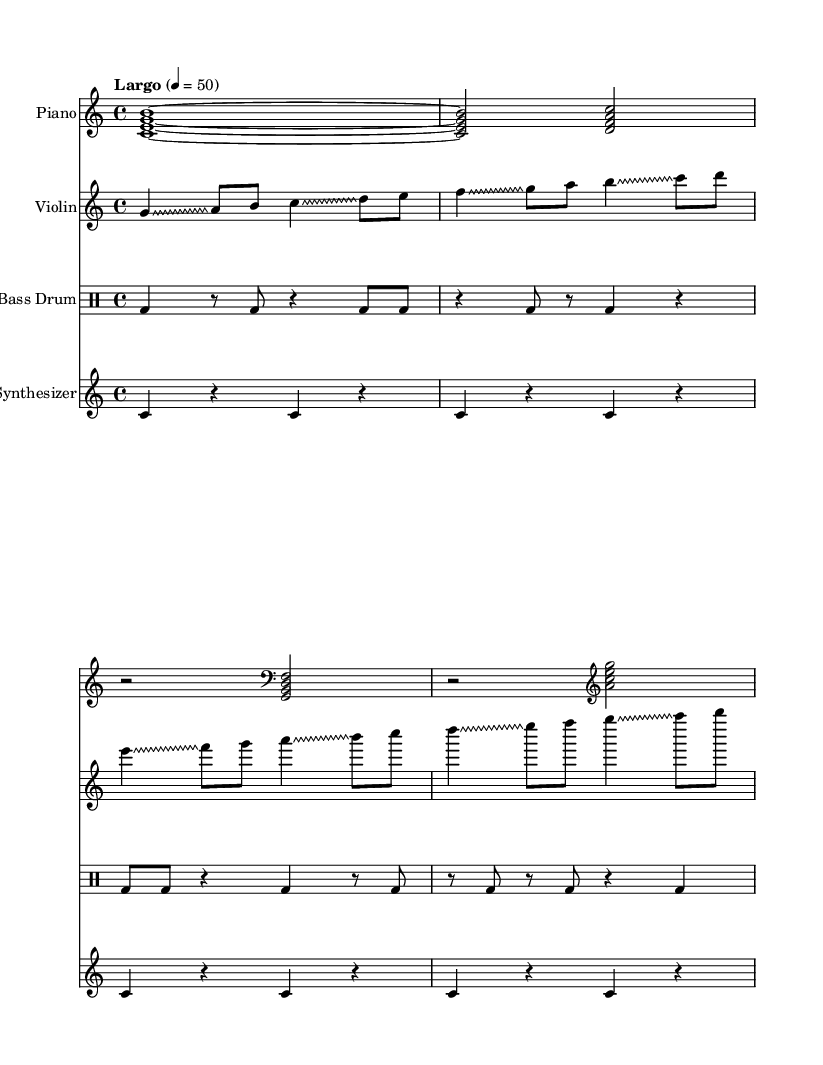What is the time signature of this music? The time signature is indicated at the beginning of the score, shown as "4/4", which means there are four beats in each measure and each beat is a quarter note.
Answer: 4/4 What is the tempo marking for the piece? The tempo marking is specified at the beginning as "Largo" with a metronome marking of 50 beats per minute, indicating a slow pace.
Answer: Largo, 50 Which instrument plays the highest pitch notes? The violin part is written in the treble clef and contains the highest pitches, as indicated by the relative note placements compared to other instruments.
Answer: Violin How many measures does the piano part contain? The piano part is made up of four measures, as indicated by the structure seen in the staff with four distinct divisions.
Answer: 4 What type of drum notation is used in this piece? The piece features a bass drum notated in a specific style within drum notation, as indicated by the "drummode" command used in the score.
Answer: Bass Drum Which technique does the violin employ predominantly throughout? The violin throughout predominantly uses glissando, a technique that involves sliding between pitches, as indicated by the notation in the score.
Answer: Glissando What is the role of the synthesizer in this score? The synthesizer in this piece uses sustained notes, indicated by repeated quarter notes with rests, providing atmospheric or harmonic texture alongside the other instruments.
Answer: Texture 